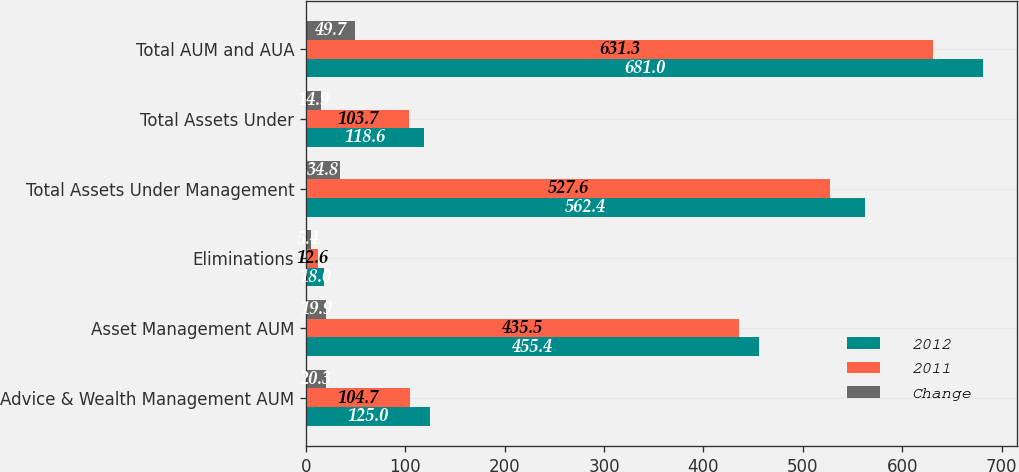<chart> <loc_0><loc_0><loc_500><loc_500><stacked_bar_chart><ecel><fcel>Advice & Wealth Management AUM<fcel>Asset Management AUM<fcel>Eliminations<fcel>Total Assets Under Management<fcel>Total Assets Under<fcel>Total AUM and AUA<nl><fcel>2012<fcel>125<fcel>455.4<fcel>18<fcel>562.4<fcel>118.6<fcel>681<nl><fcel>2011<fcel>104.7<fcel>435.5<fcel>12.6<fcel>527.6<fcel>103.7<fcel>631.3<nl><fcel>Change<fcel>20.3<fcel>19.9<fcel>5.4<fcel>34.8<fcel>14.9<fcel>49.7<nl></chart> 